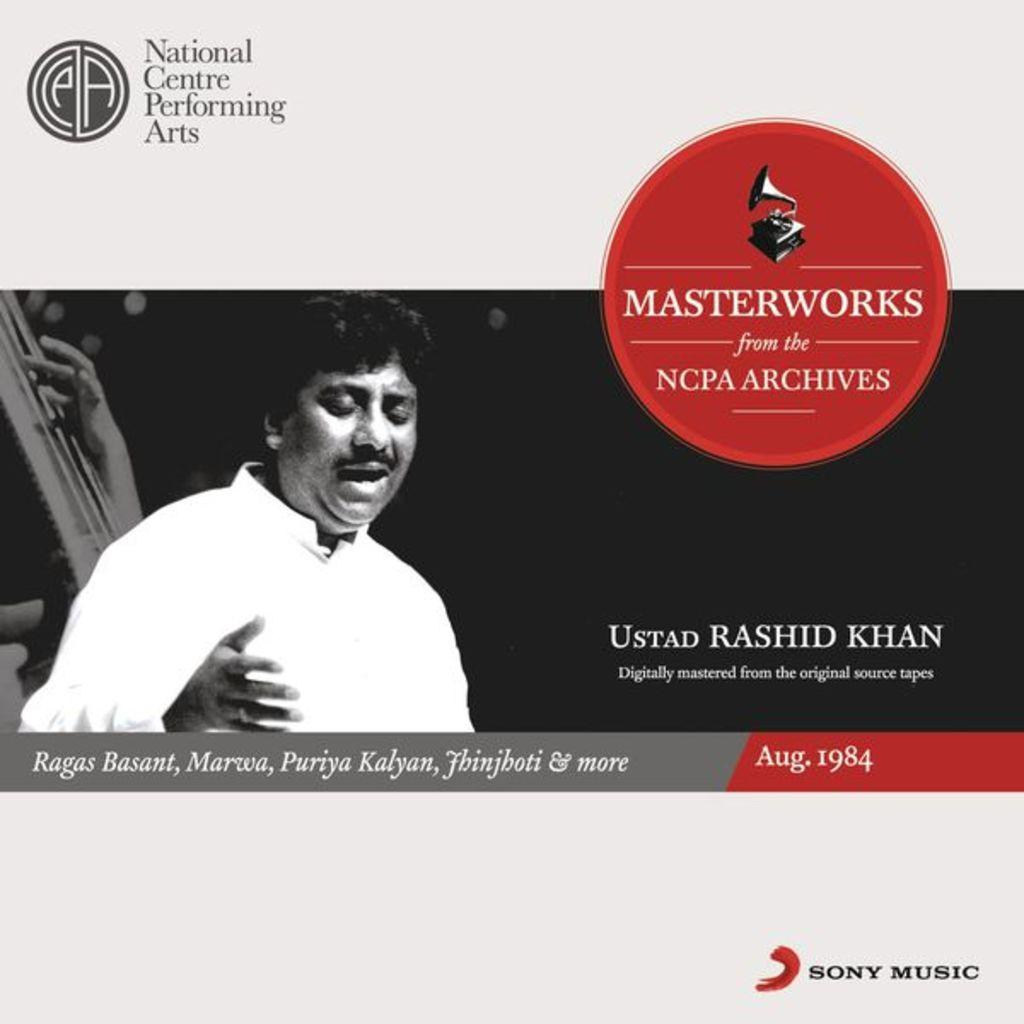What is the main subject of the image? There is a black and white photo of a man in the image. Are there any additional elements in the image besides the photo? Yes, there are logos visible in the image. Is there any text present in the image? Yes, there is something written on the image. Is there a desk visible in the image? No, there is no desk present in the image. Can you see any signs of burning in the image? No, there are no signs of burning visible in the image. 